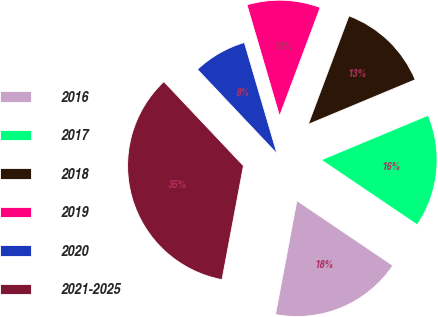Convert chart to OTSL. <chart><loc_0><loc_0><loc_500><loc_500><pie_chart><fcel>2016<fcel>2017<fcel>2018<fcel>2019<fcel>2020<fcel>2021-2025<nl><fcel>18.5%<fcel>15.75%<fcel>13.0%<fcel>10.25%<fcel>7.51%<fcel>34.99%<nl></chart> 